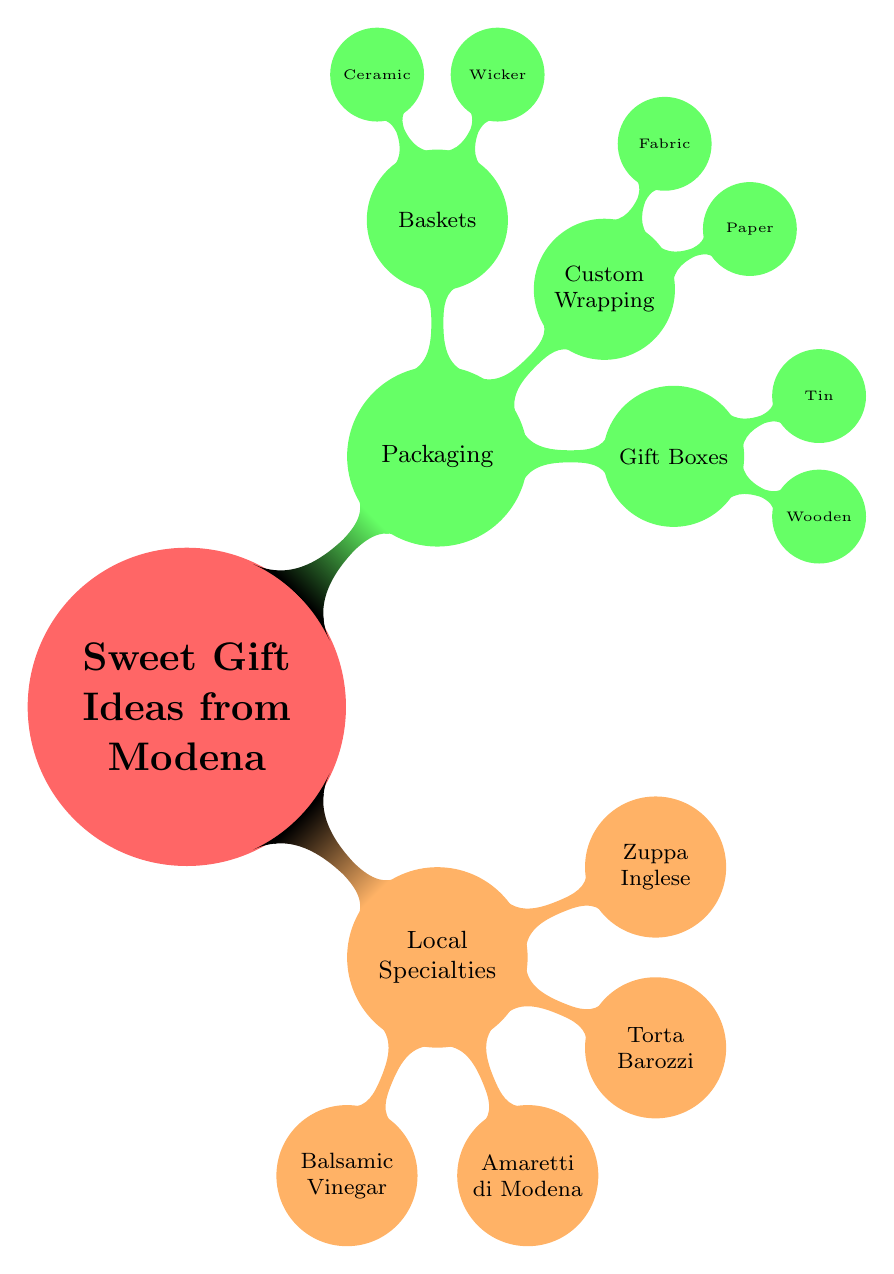What are the local specialties featured in the diagram? The diagram lists four local specialties under the "Local Specialties" node: Balsamic Vinegar, Amaretti di Modena, Torta Barozzi, and Zuppa Inglese.
Answer: Balsamic Vinegar, Amaretti di Modena, Torta Barozzi, Zuppa Inglese What types of gift boxes are mentioned? The gift boxes node specifies two types: Wooden Boxes and Decorative Tin Boxes.
Answer: Wooden Boxes, Decorative Tin Boxes How many producers are listed for Amaretti di Modena? In the diagram, the "Amaretti di Modena" node references two producers: Panificio Modenese and Antica Pasticceria San Biagio, indicating a total of two producers.
Answer: 2 Which local specialty has a description that includes "rich, dense chocolate"? The "Torta Barozzi" node describes it as a rich, dense chocolate cake, linking the description directly to this specialty.
Answer: Torta Barozzi What materials are suggested for custom wrapping? The "Custom Wrapping" node outlines two materials: Handmade Paper and Fabric Wraps, showing specific options available for wrapping.
Answer: Handmade Paper, Fabric Wraps 